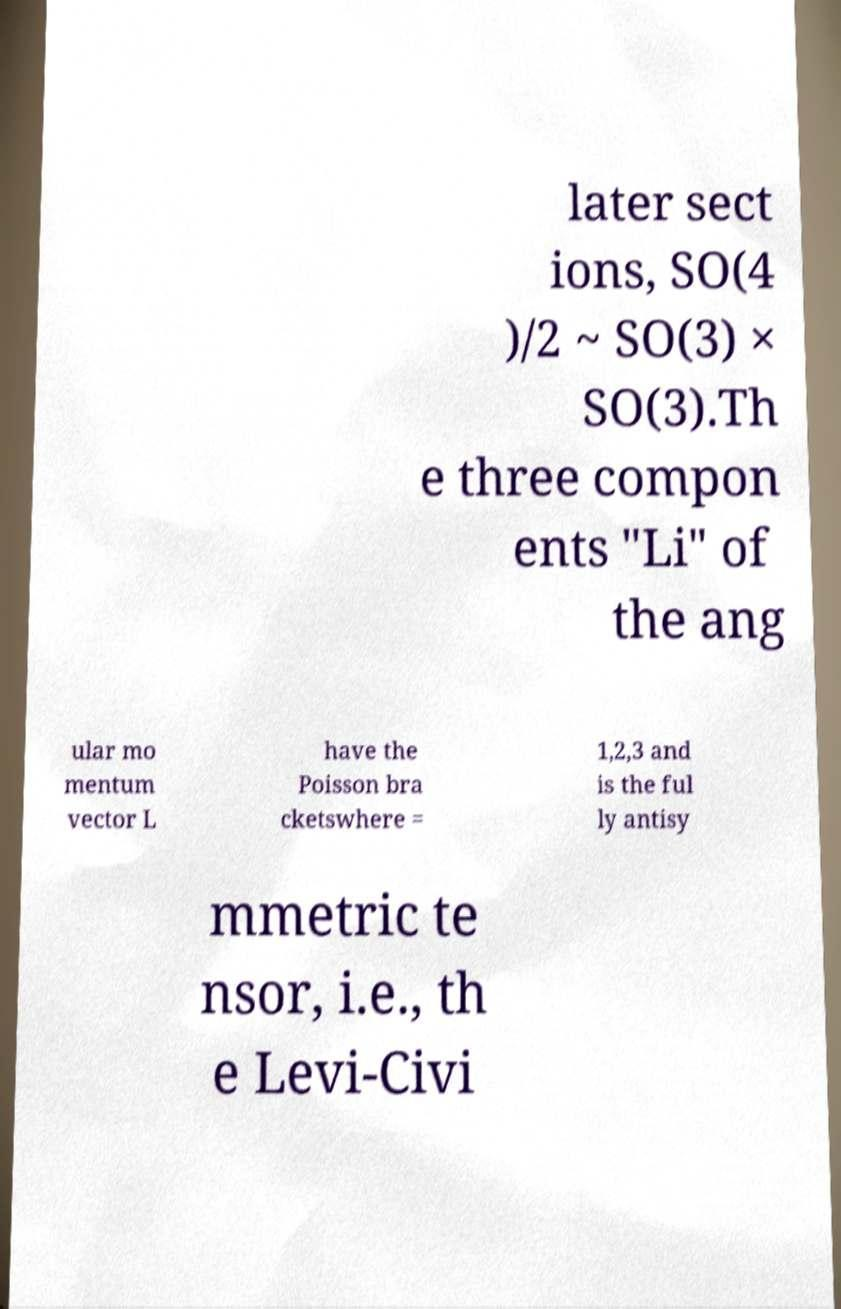Please read and relay the text visible in this image. What does it say? later sect ions, SO(4 )/2 ~ SO(3) × SO(3).Th e three compon ents "Li" of the ang ular mo mentum vector L have the Poisson bra cketswhere = 1,2,3 and is the ful ly antisy mmetric te nsor, i.e., th e Levi-Civi 